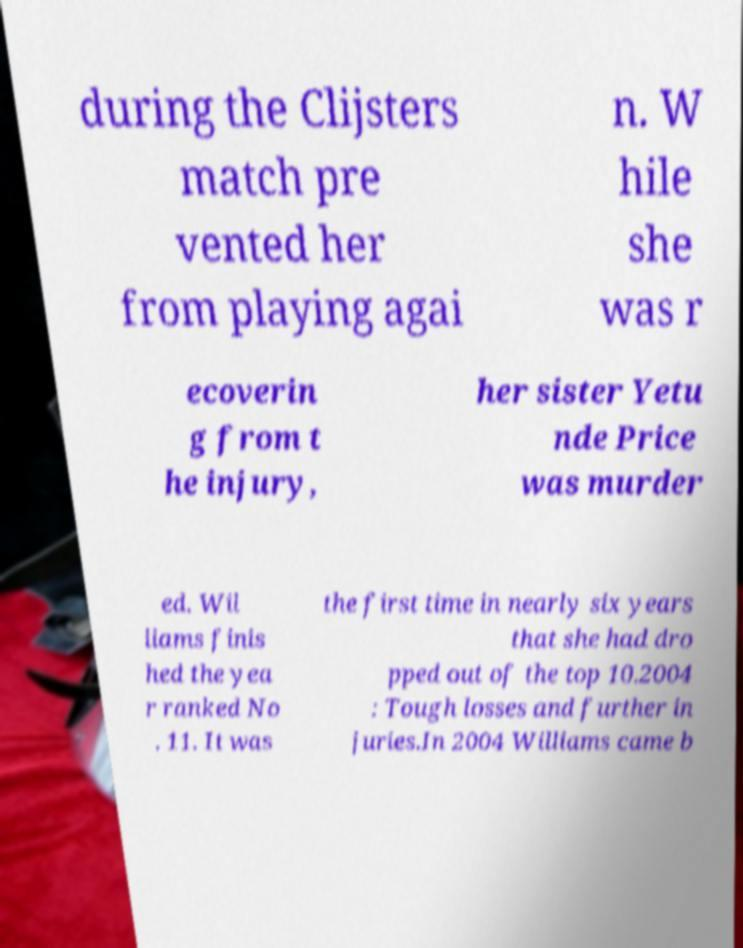There's text embedded in this image that I need extracted. Can you transcribe it verbatim? during the Clijsters match pre vented her from playing agai n. W hile she was r ecoverin g from t he injury, her sister Yetu nde Price was murder ed. Wil liams finis hed the yea r ranked No . 11. It was the first time in nearly six years that she had dro pped out of the top 10.2004 : Tough losses and further in juries.In 2004 Williams came b 